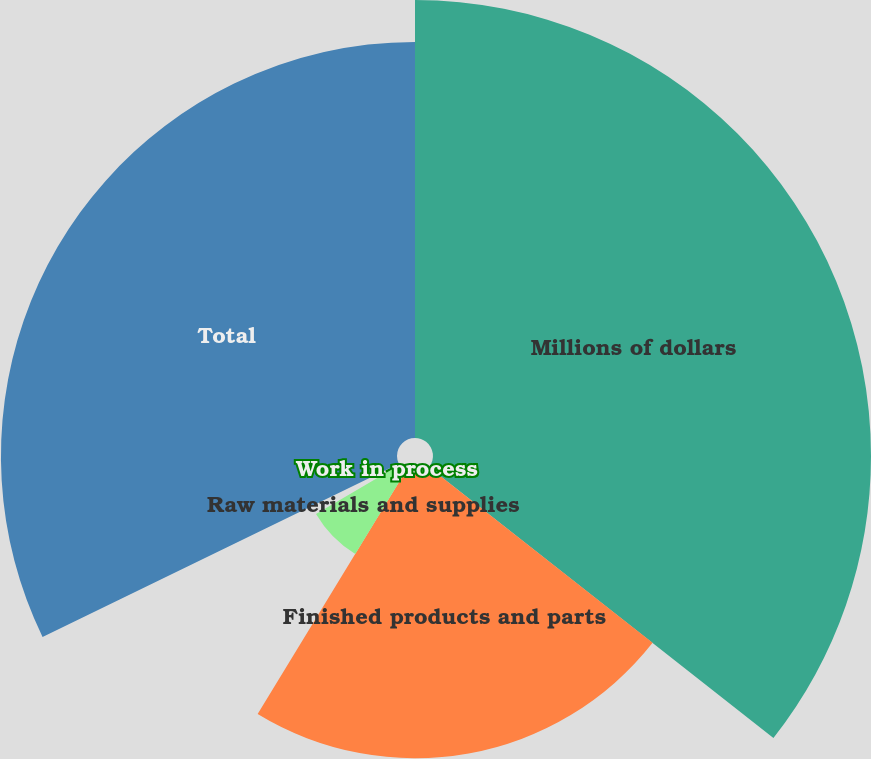Convert chart. <chart><loc_0><loc_0><loc_500><loc_500><pie_chart><fcel>Millions of dollars<fcel>Finished products and parts<fcel>Raw materials and supplies<fcel>Work in process<fcel>Total<nl><fcel>35.61%<fcel>23.11%<fcel>7.86%<fcel>1.23%<fcel>32.2%<nl></chart> 